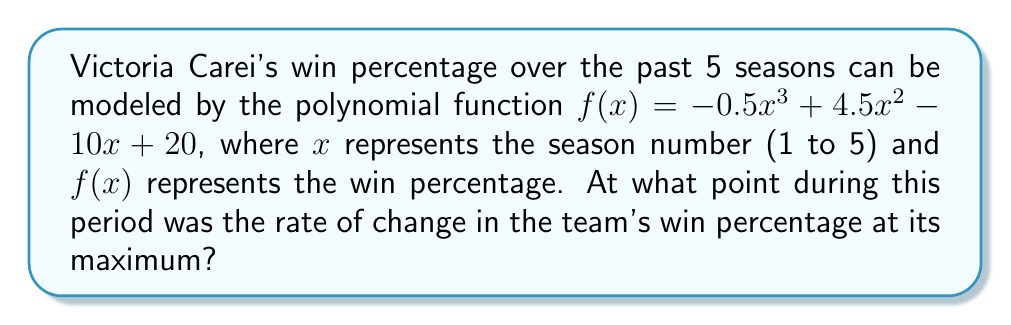Give your solution to this math problem. To find the point where the rate of change in the team's win percentage is at its maximum, we need to follow these steps:

1) The rate of change is represented by the first derivative of the function. Let's find $f'(x)$:
   
   $f'(x) = -1.5x^2 + 9x - 10$

2) The maximum rate of change occurs where the second derivative equals zero. Let's find $f''(x)$:
   
   $f''(x) = -3x + 9$

3) Set $f''(x) = 0$ and solve for $x$:
   
   $-3x + 9 = 0$
   $-3x = -9$
   $x = 3$

4) To confirm this is a maximum (not a minimum), we can check that $f'''(x) < 0$:
   
   $f'''(x) = -3$, which is indeed negative.

5) Therefore, the rate of change is at its maximum when $x = 3$, which corresponds to the 3rd season.

6) To find the exact win percentage at this point, we substitute $x = 3$ into the original function:

   $f(3) = -0.5(3)^3 + 4.5(3)^2 - 10(3) + 20$
         $= -13.5 + 40.5 - 30 + 20$
         $= 17$

So, the win percentage at this point was 17%.
Answer: 3rd season, when win percentage was 17% 